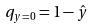Convert formula to latex. <formula><loc_0><loc_0><loc_500><loc_500>q _ { y = 0 } = 1 - \hat { y }</formula> 